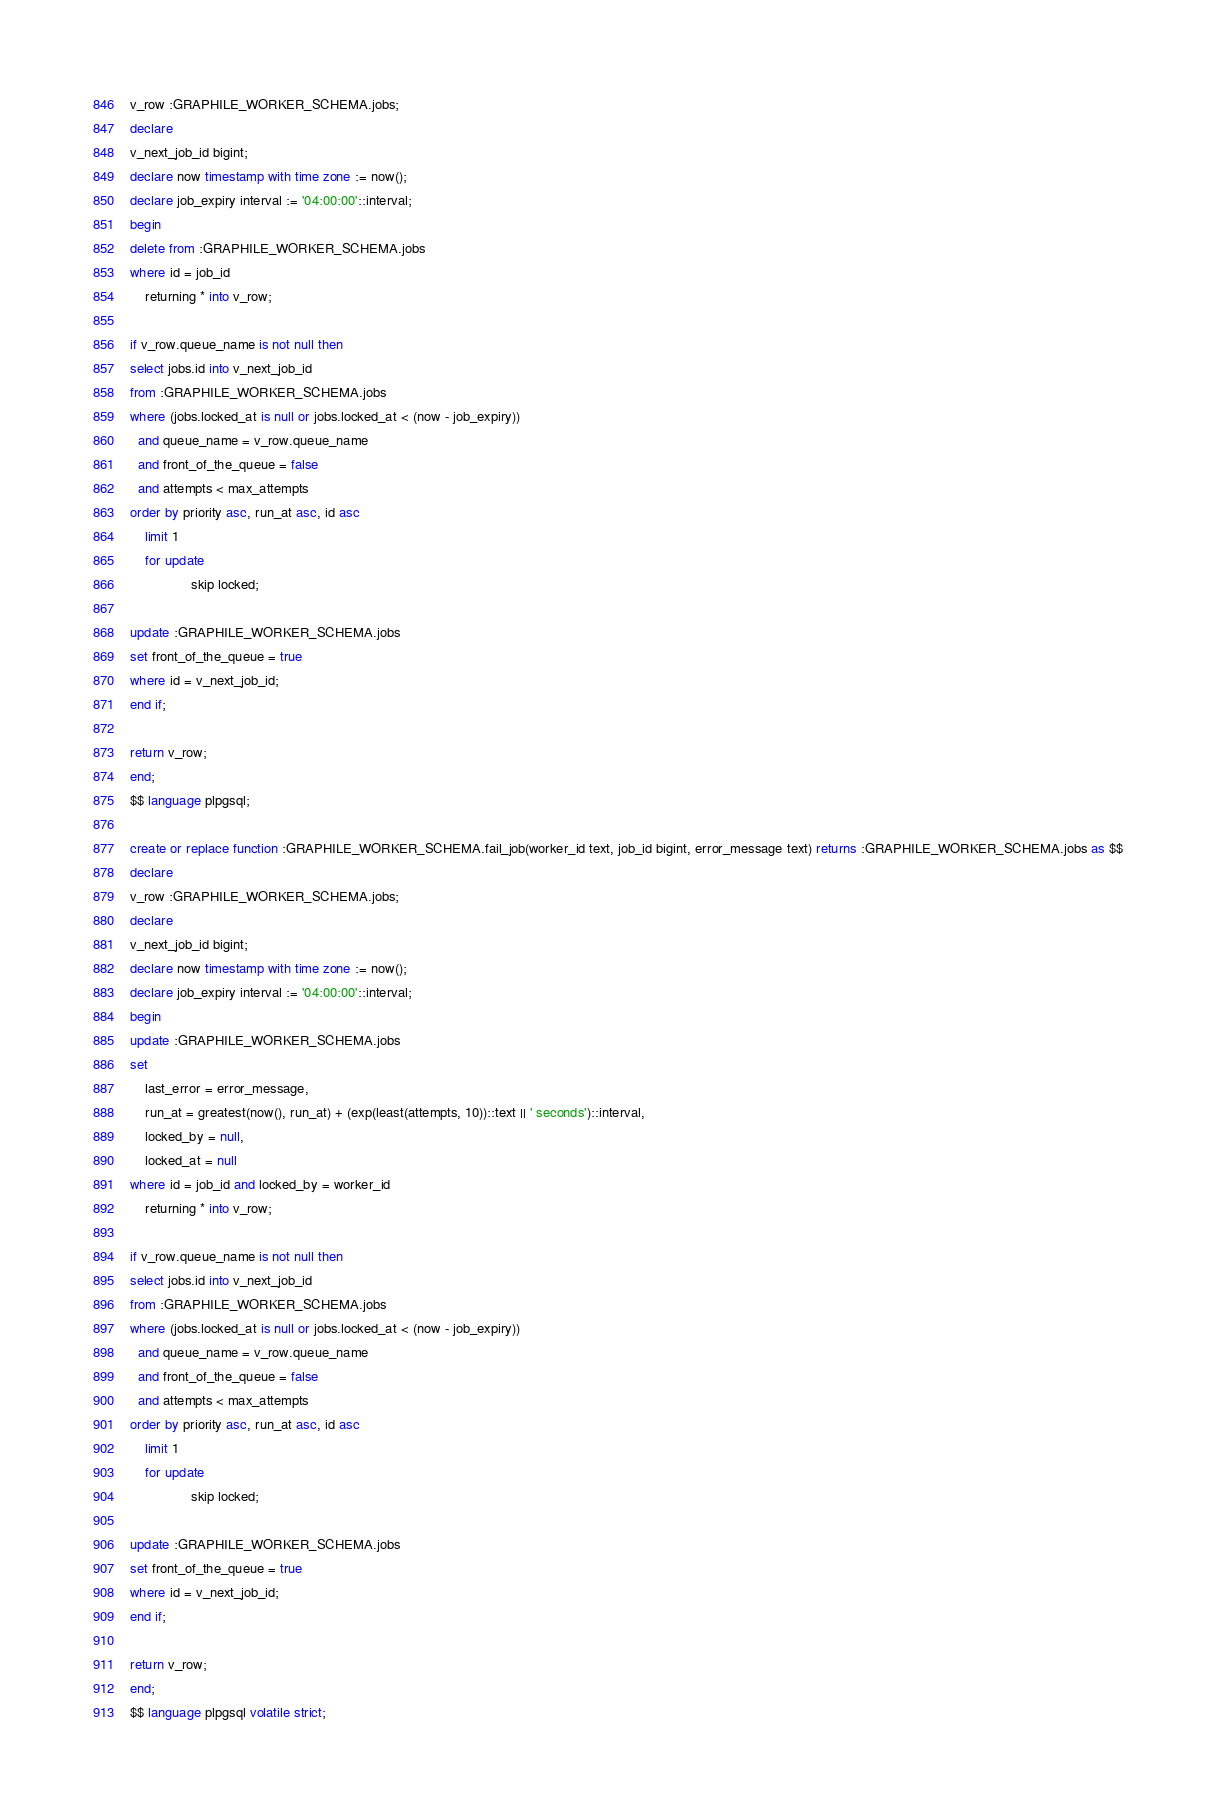Convert code to text. <code><loc_0><loc_0><loc_500><loc_500><_SQL_>v_row :GRAPHILE_WORKER_SCHEMA.jobs;
declare
v_next_job_id bigint;
declare now timestamp with time zone := now();
declare job_expiry interval := '04:00:00'::interval;
begin
delete from :GRAPHILE_WORKER_SCHEMA.jobs
where id = job_id
    returning * into v_row;

if v_row.queue_name is not null then
select jobs.id into v_next_job_id
from :GRAPHILE_WORKER_SCHEMA.jobs
where (jobs.locked_at is null or jobs.locked_at < (now - job_expiry))
  and queue_name = v_row.queue_name
  and front_of_the_queue = false
  and attempts < max_attempts
order by priority asc, run_at asc, id asc
    limit 1
    for update
                skip locked;

update :GRAPHILE_WORKER_SCHEMA.jobs
set front_of_the_queue = true
where id = v_next_job_id;
end if;

return v_row;
end;
$$ language plpgsql;

create or replace function :GRAPHILE_WORKER_SCHEMA.fail_job(worker_id text, job_id bigint, error_message text) returns :GRAPHILE_WORKER_SCHEMA.jobs as $$
declare
v_row :GRAPHILE_WORKER_SCHEMA.jobs;
declare
v_next_job_id bigint;
declare now timestamp with time zone := now();
declare job_expiry interval := '04:00:00'::interval;
begin
update :GRAPHILE_WORKER_SCHEMA.jobs
set
    last_error = error_message,
    run_at = greatest(now(), run_at) + (exp(least(attempts, 10))::text || ' seconds')::interval,
    locked_by = null,
    locked_at = null
where id = job_id and locked_by = worker_id
    returning * into v_row;

if v_row.queue_name is not null then
select jobs.id into v_next_job_id
from :GRAPHILE_WORKER_SCHEMA.jobs
where (jobs.locked_at is null or jobs.locked_at < (now - job_expiry))
  and queue_name = v_row.queue_name
  and front_of_the_queue = false
  and attempts < max_attempts
order by priority asc, run_at asc, id asc
    limit 1
    for update
                skip locked;

update :GRAPHILE_WORKER_SCHEMA.jobs
set front_of_the_queue = true
where id = v_next_job_id;
end if;

return v_row;
end;
$$ language plpgsql volatile strict;
</code> 